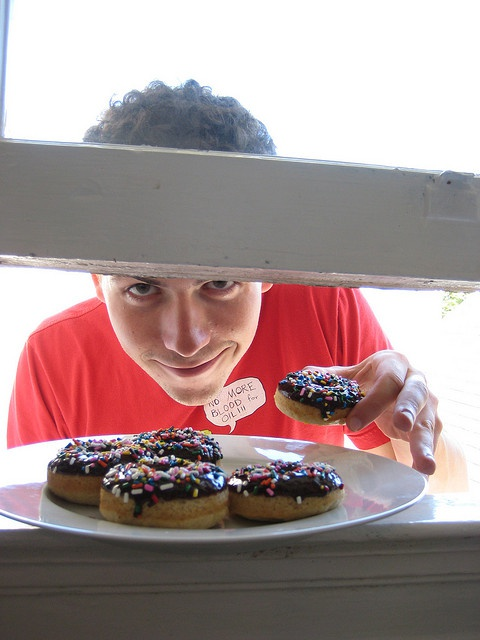Describe the objects in this image and their specific colors. I can see people in lavender, brown, and salmon tones, donut in lavender, maroon, black, and gray tones, donut in lavender, black, maroon, and gray tones, donut in lavender, black, maroon, and gray tones, and donut in lavender, maroon, black, and gray tones in this image. 